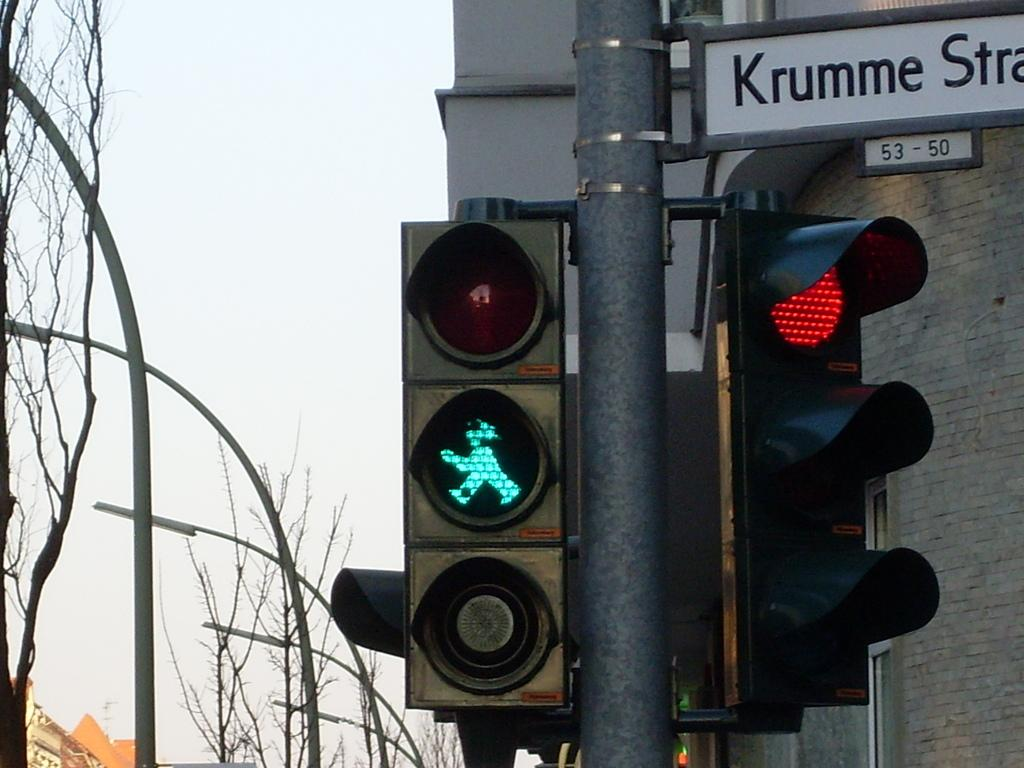<image>
Give a short and clear explanation of the subsequent image. A traffic light with a street sign reading Krumme Strat. 